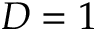<formula> <loc_0><loc_0><loc_500><loc_500>D = 1</formula> 